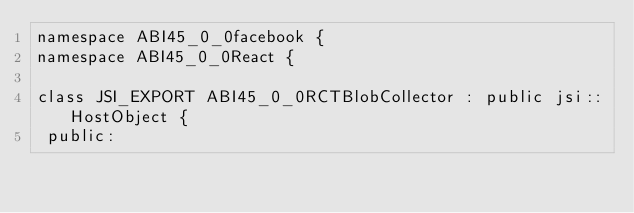<code> <loc_0><loc_0><loc_500><loc_500><_C_>namespace ABI45_0_0facebook {
namespace ABI45_0_0React {

class JSI_EXPORT ABI45_0_0RCTBlobCollector : public jsi::HostObject {
 public:</code> 